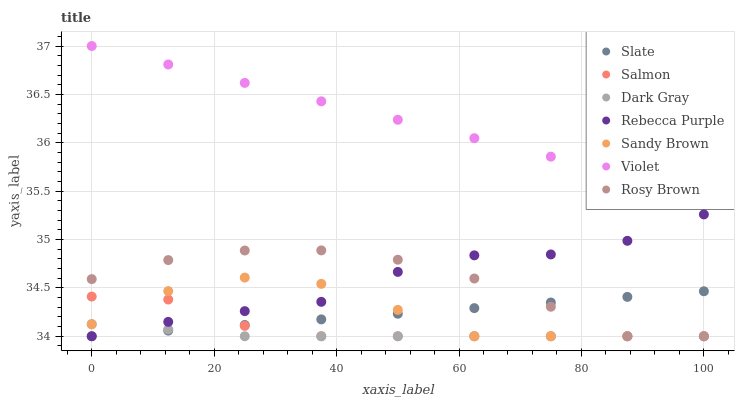Does Dark Gray have the minimum area under the curve?
Answer yes or no. Yes. Does Violet have the maximum area under the curve?
Answer yes or no. Yes. Does Rosy Brown have the minimum area under the curve?
Answer yes or no. No. Does Rosy Brown have the maximum area under the curve?
Answer yes or no. No. Is Slate the smoothest?
Answer yes or no. Yes. Is Sandy Brown the roughest?
Answer yes or no. Yes. Is Rosy Brown the smoothest?
Answer yes or no. No. Is Rosy Brown the roughest?
Answer yes or no. No. Does Slate have the lowest value?
Answer yes or no. Yes. Does Violet have the lowest value?
Answer yes or no. No. Does Violet have the highest value?
Answer yes or no. Yes. Does Rosy Brown have the highest value?
Answer yes or no. No. Is Sandy Brown less than Violet?
Answer yes or no. Yes. Is Violet greater than Dark Gray?
Answer yes or no. Yes. Does Salmon intersect Slate?
Answer yes or no. Yes. Is Salmon less than Slate?
Answer yes or no. No. Is Salmon greater than Slate?
Answer yes or no. No. Does Sandy Brown intersect Violet?
Answer yes or no. No. 